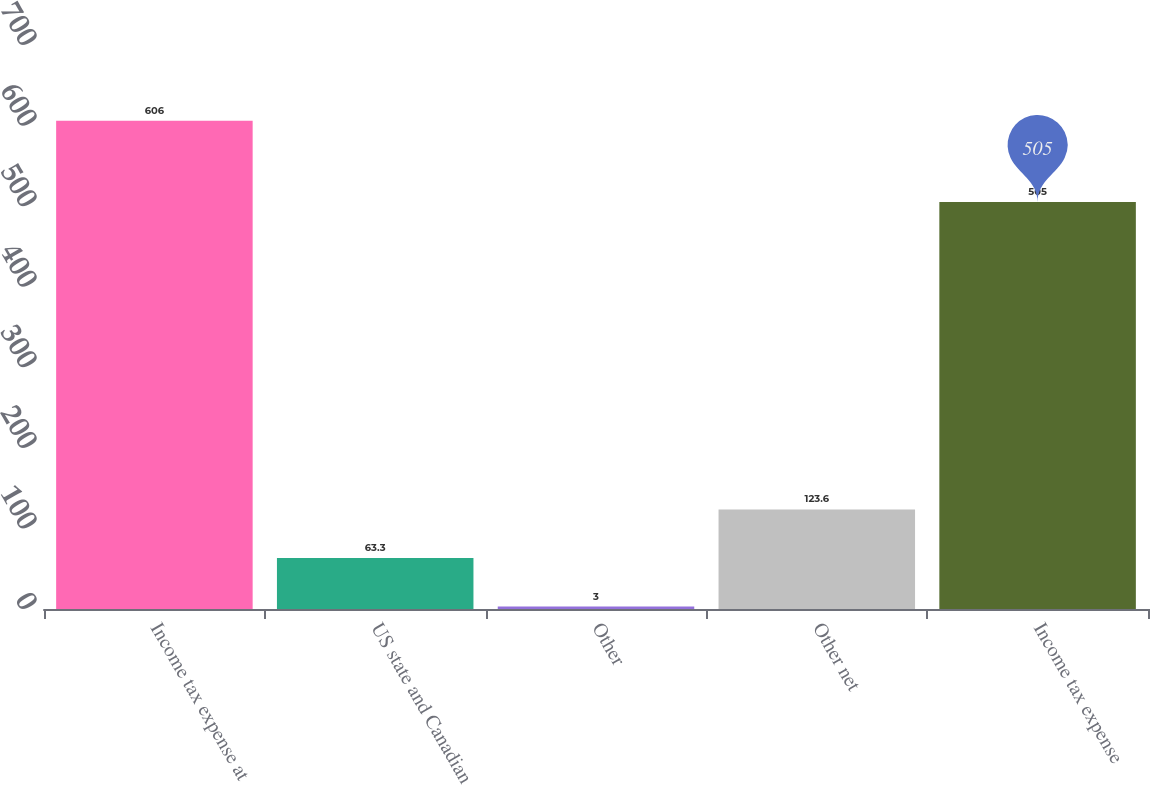<chart> <loc_0><loc_0><loc_500><loc_500><bar_chart><fcel>Income tax expense at<fcel>US state and Canadian<fcel>Other<fcel>Other net<fcel>Income tax expense<nl><fcel>606<fcel>63.3<fcel>3<fcel>123.6<fcel>505<nl></chart> 